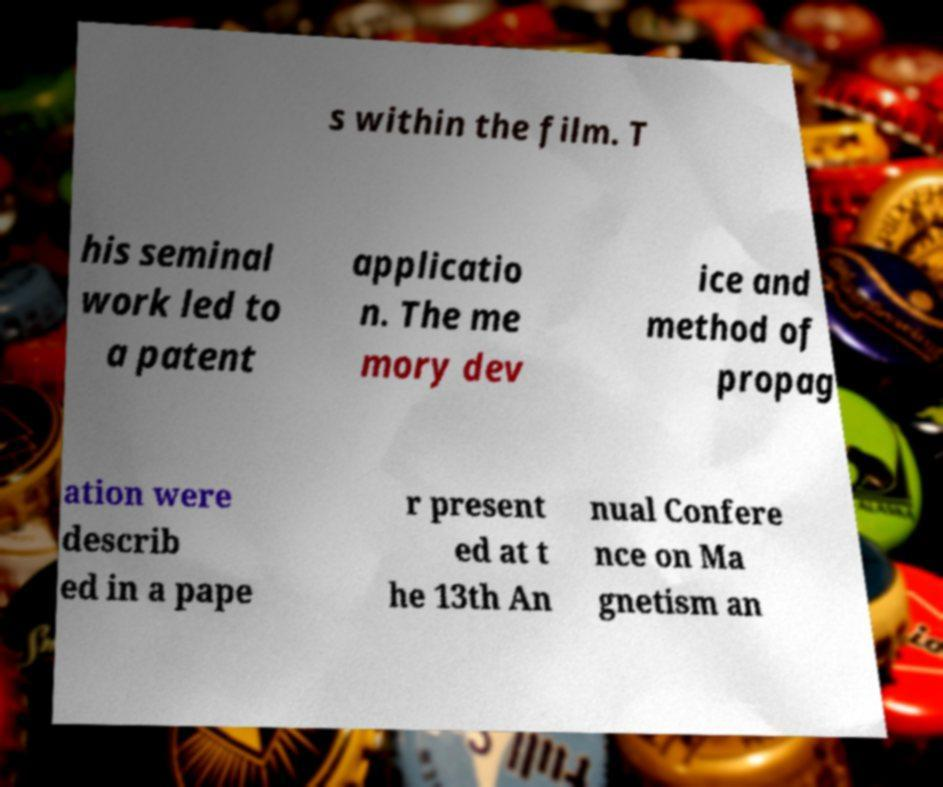Could you extract and type out the text from this image? s within the film. T his seminal work led to a patent applicatio n. The me mory dev ice and method of propag ation were describ ed in a pape r present ed at t he 13th An nual Confere nce on Ma gnetism an 